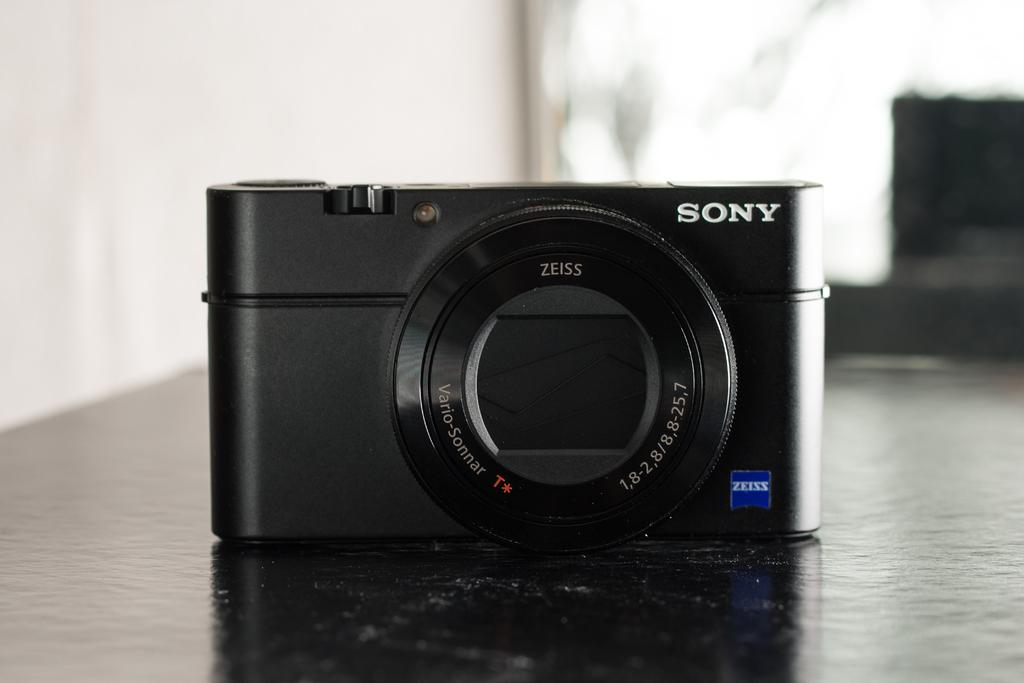Provide a one-sentence caption for the provided image. A black Sony camera on top of a black counter that says zeiss. 